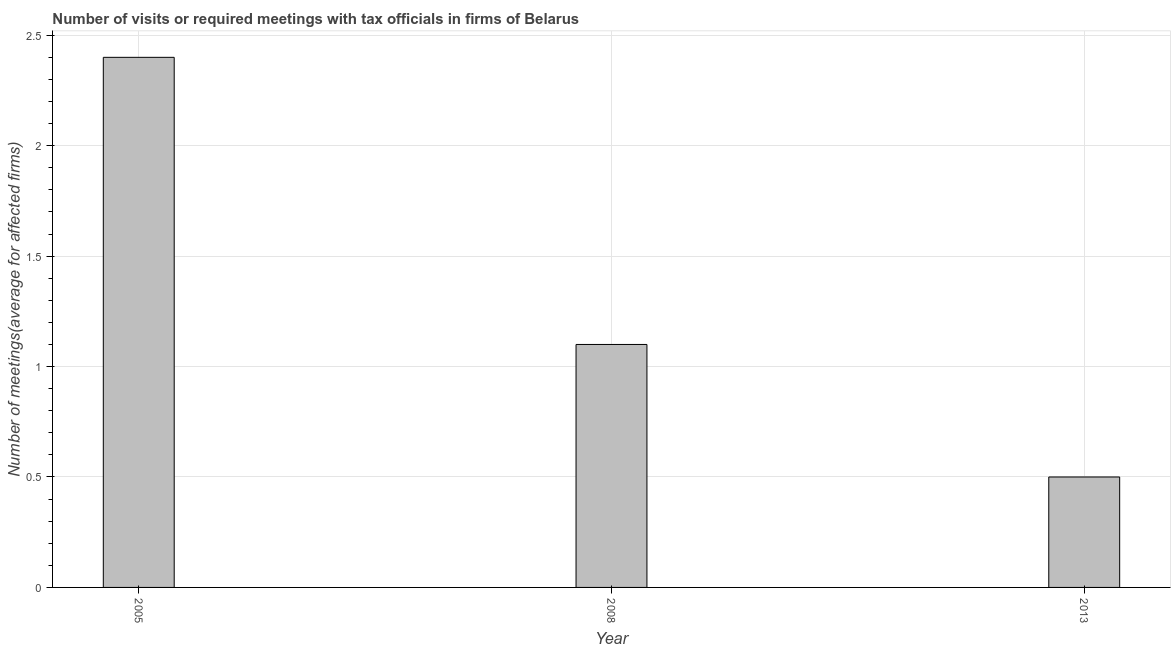Does the graph contain any zero values?
Offer a very short reply. No. Does the graph contain grids?
Your answer should be very brief. Yes. What is the title of the graph?
Your answer should be very brief. Number of visits or required meetings with tax officials in firms of Belarus. What is the label or title of the Y-axis?
Ensure brevity in your answer.  Number of meetings(average for affected firms). What is the number of required meetings with tax officials in 2005?
Your answer should be compact. 2.4. In which year was the number of required meetings with tax officials maximum?
Your answer should be very brief. 2005. What is the sum of the number of required meetings with tax officials?
Make the answer very short. 4. What is the average number of required meetings with tax officials per year?
Your response must be concise. 1.33. What is the median number of required meetings with tax officials?
Offer a terse response. 1.1. Do a majority of the years between 2013 and 2005 (inclusive) have number of required meetings with tax officials greater than 0.8 ?
Make the answer very short. Yes. What is the ratio of the number of required meetings with tax officials in 2005 to that in 2008?
Your answer should be compact. 2.18. Is the sum of the number of required meetings with tax officials in 2008 and 2013 greater than the maximum number of required meetings with tax officials across all years?
Keep it short and to the point. No. What is the difference between the highest and the lowest number of required meetings with tax officials?
Your answer should be compact. 1.9. In how many years, is the number of required meetings with tax officials greater than the average number of required meetings with tax officials taken over all years?
Offer a terse response. 1. How many bars are there?
Make the answer very short. 3. How many years are there in the graph?
Keep it short and to the point. 3. What is the Number of meetings(average for affected firms) in 2013?
Your answer should be very brief. 0.5. What is the difference between the Number of meetings(average for affected firms) in 2005 and 2013?
Provide a short and direct response. 1.9. What is the difference between the Number of meetings(average for affected firms) in 2008 and 2013?
Your response must be concise. 0.6. What is the ratio of the Number of meetings(average for affected firms) in 2005 to that in 2008?
Offer a very short reply. 2.18. What is the ratio of the Number of meetings(average for affected firms) in 2008 to that in 2013?
Your answer should be very brief. 2.2. 